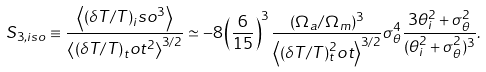Convert formula to latex. <formula><loc_0><loc_0><loc_500><loc_500>S _ { 3 , i s o } \equiv \frac { \left \langle ( \delta T / T ) _ { i } s o ^ { 3 } \right \rangle } { \left \langle ( \delta T / T ) _ { t } o t ^ { 2 } \right \rangle ^ { 3 / 2 } } \simeq - 8 \left ( \frac { 6 } { 1 5 } \right ) ^ { 3 } \frac { ( \Omega _ { a } / \Omega _ { m } ) ^ { 3 } } { \left \langle ( \delta T / T ) ^ { 2 } _ { t } o t \right \rangle ^ { 3 / 2 } } \sigma _ { \theta } ^ { 4 } \frac { 3 \theta _ { i } ^ { 2 } + \sigma _ { \theta } ^ { 2 } } { ( \theta _ { i } ^ { 2 } + \sigma _ { \theta } ^ { 2 } ) ^ { 3 } } .</formula> 